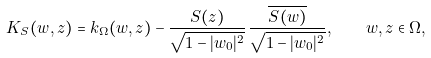<formula> <loc_0><loc_0><loc_500><loc_500>K _ { S } ( w , z ) = k _ { \Omega } ( w , z ) - \frac { S ( z ) } { \sqrt { 1 - | w _ { 0 } | ^ { 2 } } } \, \frac { \overline { S ( w ) } } { \sqrt { 1 - | w _ { 0 } | ^ { 2 } } } , \quad w , z \in \Omega ,</formula> 